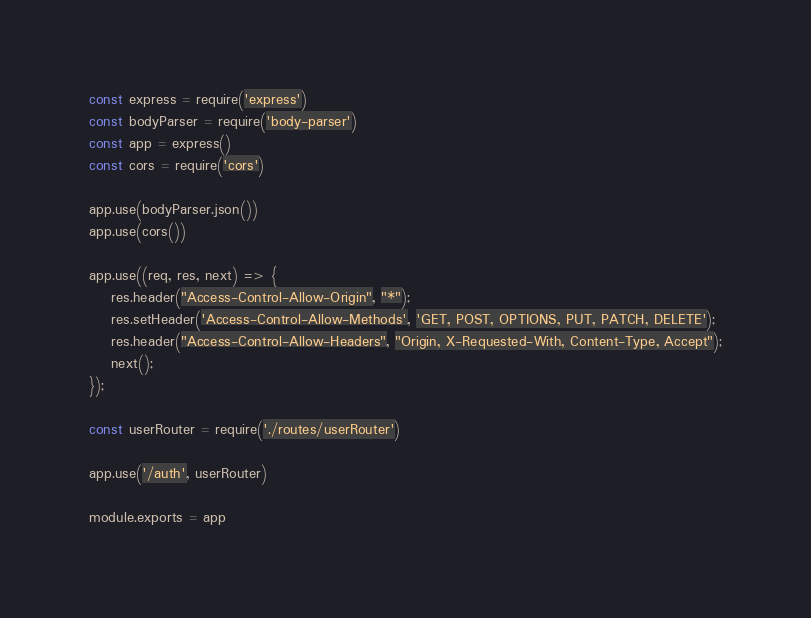Convert code to text. <code><loc_0><loc_0><loc_500><loc_500><_JavaScript_>const express = require('express')
const bodyParser = require('body-parser')
const app = express()
const cors = require('cors')

app.use(bodyParser.json())
app.use(cors())

app.use((req, res, next) => {
    res.header("Access-Control-Allow-Origin", "*");
    res.setHeader('Access-Control-Allow-Methods', 'GET, POST, OPTIONS, PUT, PATCH, DELETE');
    res.header("Access-Control-Allow-Headers", "Origin, X-Requested-With, Content-Type, Accept");
    next();
});

const userRouter = require('./routes/userRouter')

app.use('/auth', userRouter)

module.exports = app</code> 